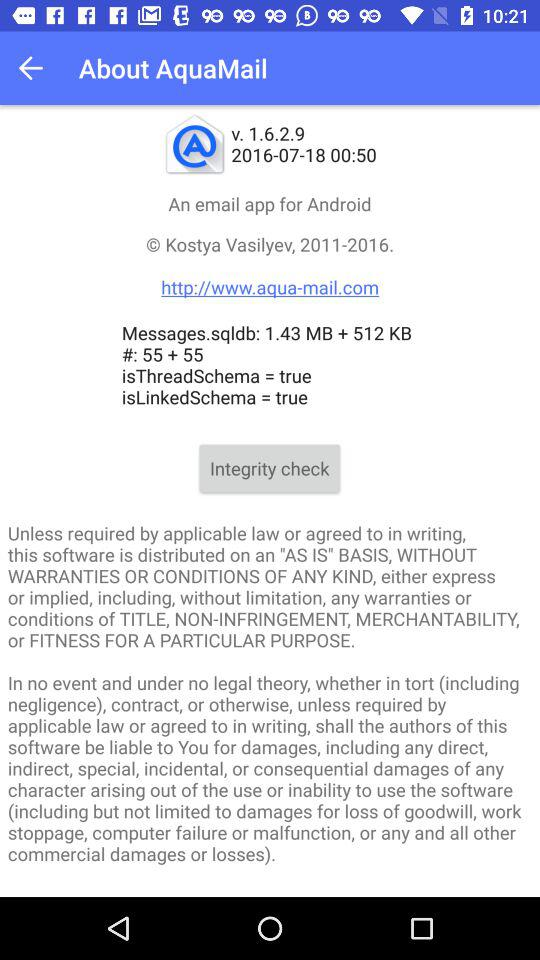What is the given website address? The given website address is http://www.aqua-mail.com. 